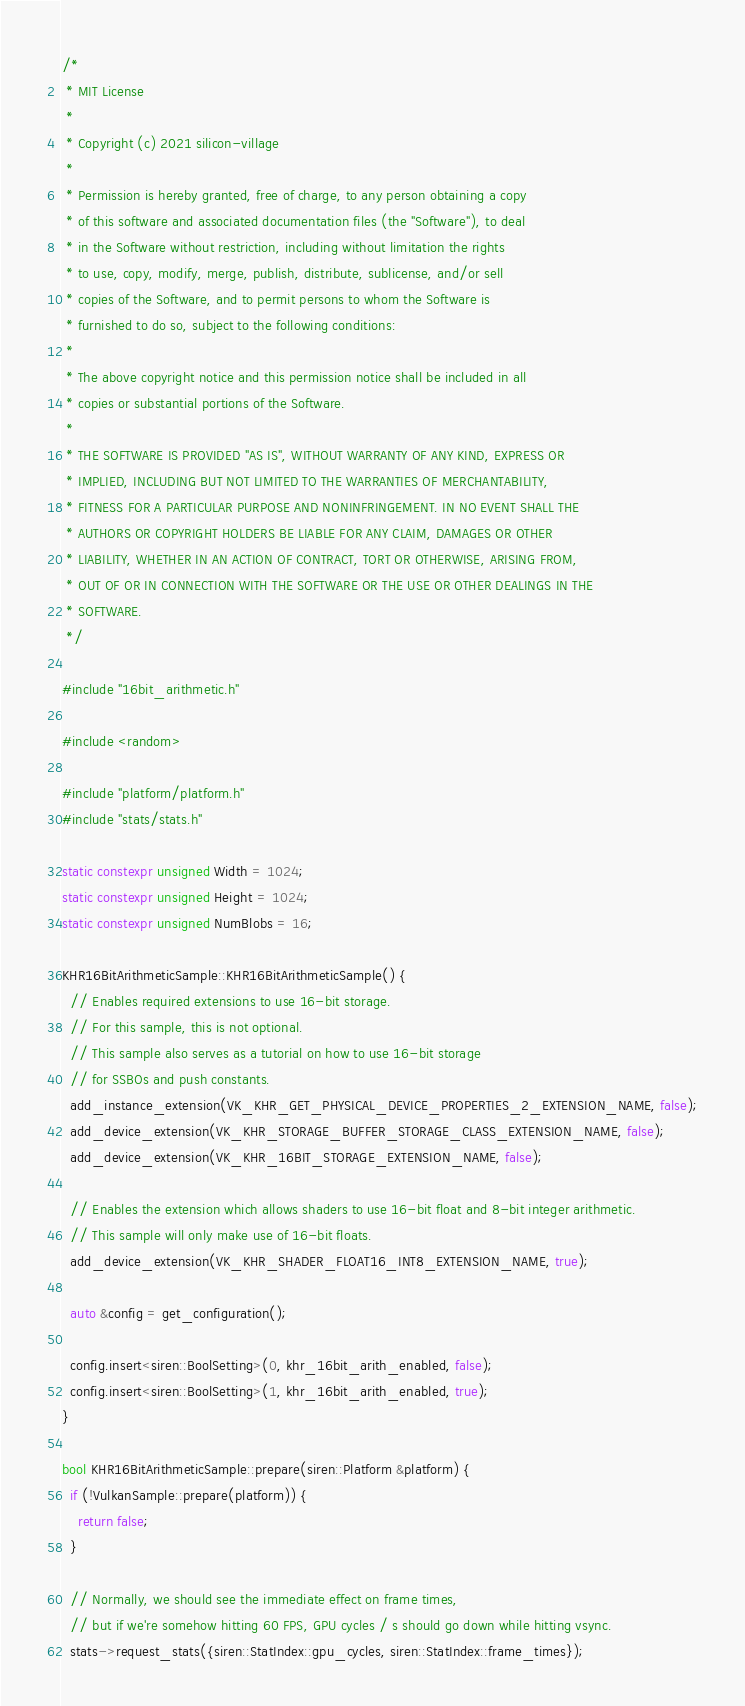<code> <loc_0><loc_0><loc_500><loc_500><_C++_>/*
 * MIT License
 *
 * Copyright (c) 2021 silicon-village
 *
 * Permission is hereby granted, free of charge, to any person obtaining a copy
 * of this software and associated documentation files (the "Software"), to deal
 * in the Software without restriction, including without limitation the rights
 * to use, copy, modify, merge, publish, distribute, sublicense, and/or sell
 * copies of the Software, and to permit persons to whom the Software is
 * furnished to do so, subject to the following conditions:
 *
 * The above copyright notice and this permission notice shall be included in all
 * copies or substantial portions of the Software.
 *
 * THE SOFTWARE IS PROVIDED "AS IS", WITHOUT WARRANTY OF ANY KIND, EXPRESS OR
 * IMPLIED, INCLUDING BUT NOT LIMITED TO THE WARRANTIES OF MERCHANTABILITY,
 * FITNESS FOR A PARTICULAR PURPOSE AND NONINFRINGEMENT. IN NO EVENT SHALL THE
 * AUTHORS OR COPYRIGHT HOLDERS BE LIABLE FOR ANY CLAIM, DAMAGES OR OTHER
 * LIABILITY, WHETHER IN AN ACTION OF CONTRACT, TORT OR OTHERWISE, ARISING FROM,
 * OUT OF OR IN CONNECTION WITH THE SOFTWARE OR THE USE OR OTHER DEALINGS IN THE
 * SOFTWARE.
 */

#include "16bit_arithmetic.h"

#include <random>

#include "platform/platform.h"
#include "stats/stats.h"

static constexpr unsigned Width = 1024;
static constexpr unsigned Height = 1024;
static constexpr unsigned NumBlobs = 16;

KHR16BitArithmeticSample::KHR16BitArithmeticSample() {
  // Enables required extensions to use 16-bit storage.
  // For this sample, this is not optional.
  // This sample also serves as a tutorial on how to use 16-bit storage
  // for SSBOs and push constants.
  add_instance_extension(VK_KHR_GET_PHYSICAL_DEVICE_PROPERTIES_2_EXTENSION_NAME, false);
  add_device_extension(VK_KHR_STORAGE_BUFFER_STORAGE_CLASS_EXTENSION_NAME, false);
  add_device_extension(VK_KHR_16BIT_STORAGE_EXTENSION_NAME, false);

  // Enables the extension which allows shaders to use 16-bit float and 8-bit integer arithmetic.
  // This sample will only make use of 16-bit floats.
  add_device_extension(VK_KHR_SHADER_FLOAT16_INT8_EXTENSION_NAME, true);

  auto &config = get_configuration();

  config.insert<siren::BoolSetting>(0, khr_16bit_arith_enabled, false);
  config.insert<siren::BoolSetting>(1, khr_16bit_arith_enabled, true);
}

bool KHR16BitArithmeticSample::prepare(siren::Platform &platform) {
  if (!VulkanSample::prepare(platform)) {
    return false;
  }

  // Normally, we should see the immediate effect on frame times,
  // but if we're somehow hitting 60 FPS, GPU cycles / s should go down while hitting vsync.
  stats->request_stats({siren::StatIndex::gpu_cycles, siren::StatIndex::frame_times});</code> 